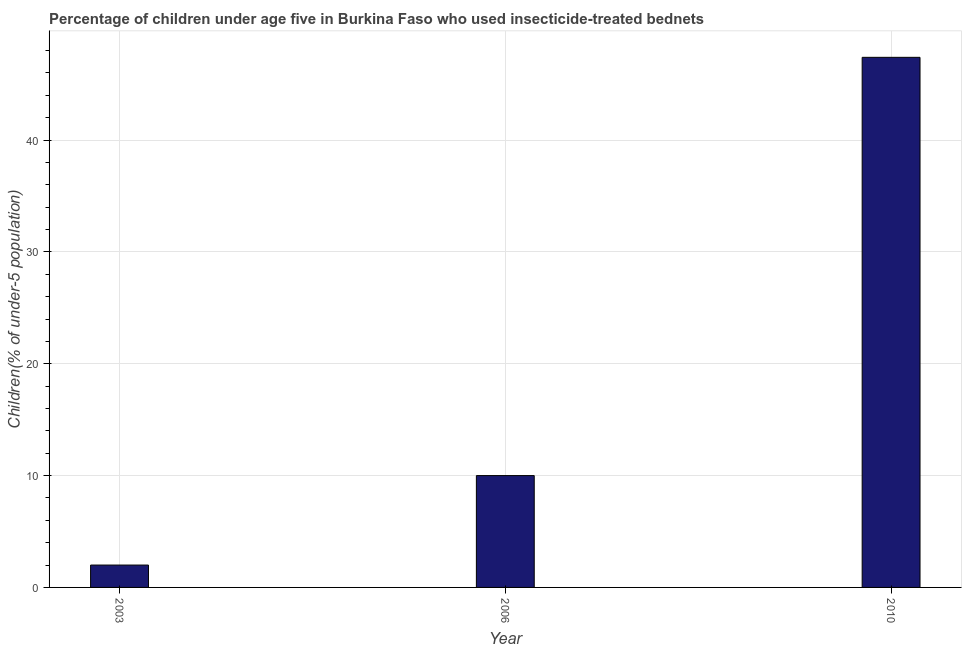Does the graph contain any zero values?
Your response must be concise. No. What is the title of the graph?
Your answer should be very brief. Percentage of children under age five in Burkina Faso who used insecticide-treated bednets. What is the label or title of the Y-axis?
Your response must be concise. Children(% of under-5 population). Across all years, what is the maximum percentage of children who use of insecticide-treated bed nets?
Your response must be concise. 47.4. Across all years, what is the minimum percentage of children who use of insecticide-treated bed nets?
Ensure brevity in your answer.  2. What is the sum of the percentage of children who use of insecticide-treated bed nets?
Offer a terse response. 59.4. What is the difference between the percentage of children who use of insecticide-treated bed nets in 2003 and 2006?
Offer a very short reply. -8. What is the average percentage of children who use of insecticide-treated bed nets per year?
Provide a succinct answer. 19.8. In how many years, is the percentage of children who use of insecticide-treated bed nets greater than 22 %?
Your answer should be very brief. 1. Do a majority of the years between 2003 and 2010 (inclusive) have percentage of children who use of insecticide-treated bed nets greater than 26 %?
Keep it short and to the point. No. What is the ratio of the percentage of children who use of insecticide-treated bed nets in 2003 to that in 2010?
Offer a very short reply. 0.04. Is the percentage of children who use of insecticide-treated bed nets in 2006 less than that in 2010?
Ensure brevity in your answer.  Yes. Is the difference between the percentage of children who use of insecticide-treated bed nets in 2006 and 2010 greater than the difference between any two years?
Provide a succinct answer. No. What is the difference between the highest and the second highest percentage of children who use of insecticide-treated bed nets?
Ensure brevity in your answer.  37.4. Is the sum of the percentage of children who use of insecticide-treated bed nets in 2006 and 2010 greater than the maximum percentage of children who use of insecticide-treated bed nets across all years?
Provide a succinct answer. Yes. What is the difference between the highest and the lowest percentage of children who use of insecticide-treated bed nets?
Provide a short and direct response. 45.4. How many bars are there?
Give a very brief answer. 3. Are all the bars in the graph horizontal?
Your answer should be very brief. No. What is the difference between two consecutive major ticks on the Y-axis?
Make the answer very short. 10. What is the Children(% of under-5 population) in 2003?
Give a very brief answer. 2. What is the Children(% of under-5 population) in 2006?
Provide a short and direct response. 10. What is the Children(% of under-5 population) of 2010?
Offer a terse response. 47.4. What is the difference between the Children(% of under-5 population) in 2003 and 2010?
Your answer should be very brief. -45.4. What is the difference between the Children(% of under-5 population) in 2006 and 2010?
Provide a short and direct response. -37.4. What is the ratio of the Children(% of under-5 population) in 2003 to that in 2010?
Your answer should be compact. 0.04. What is the ratio of the Children(% of under-5 population) in 2006 to that in 2010?
Make the answer very short. 0.21. 